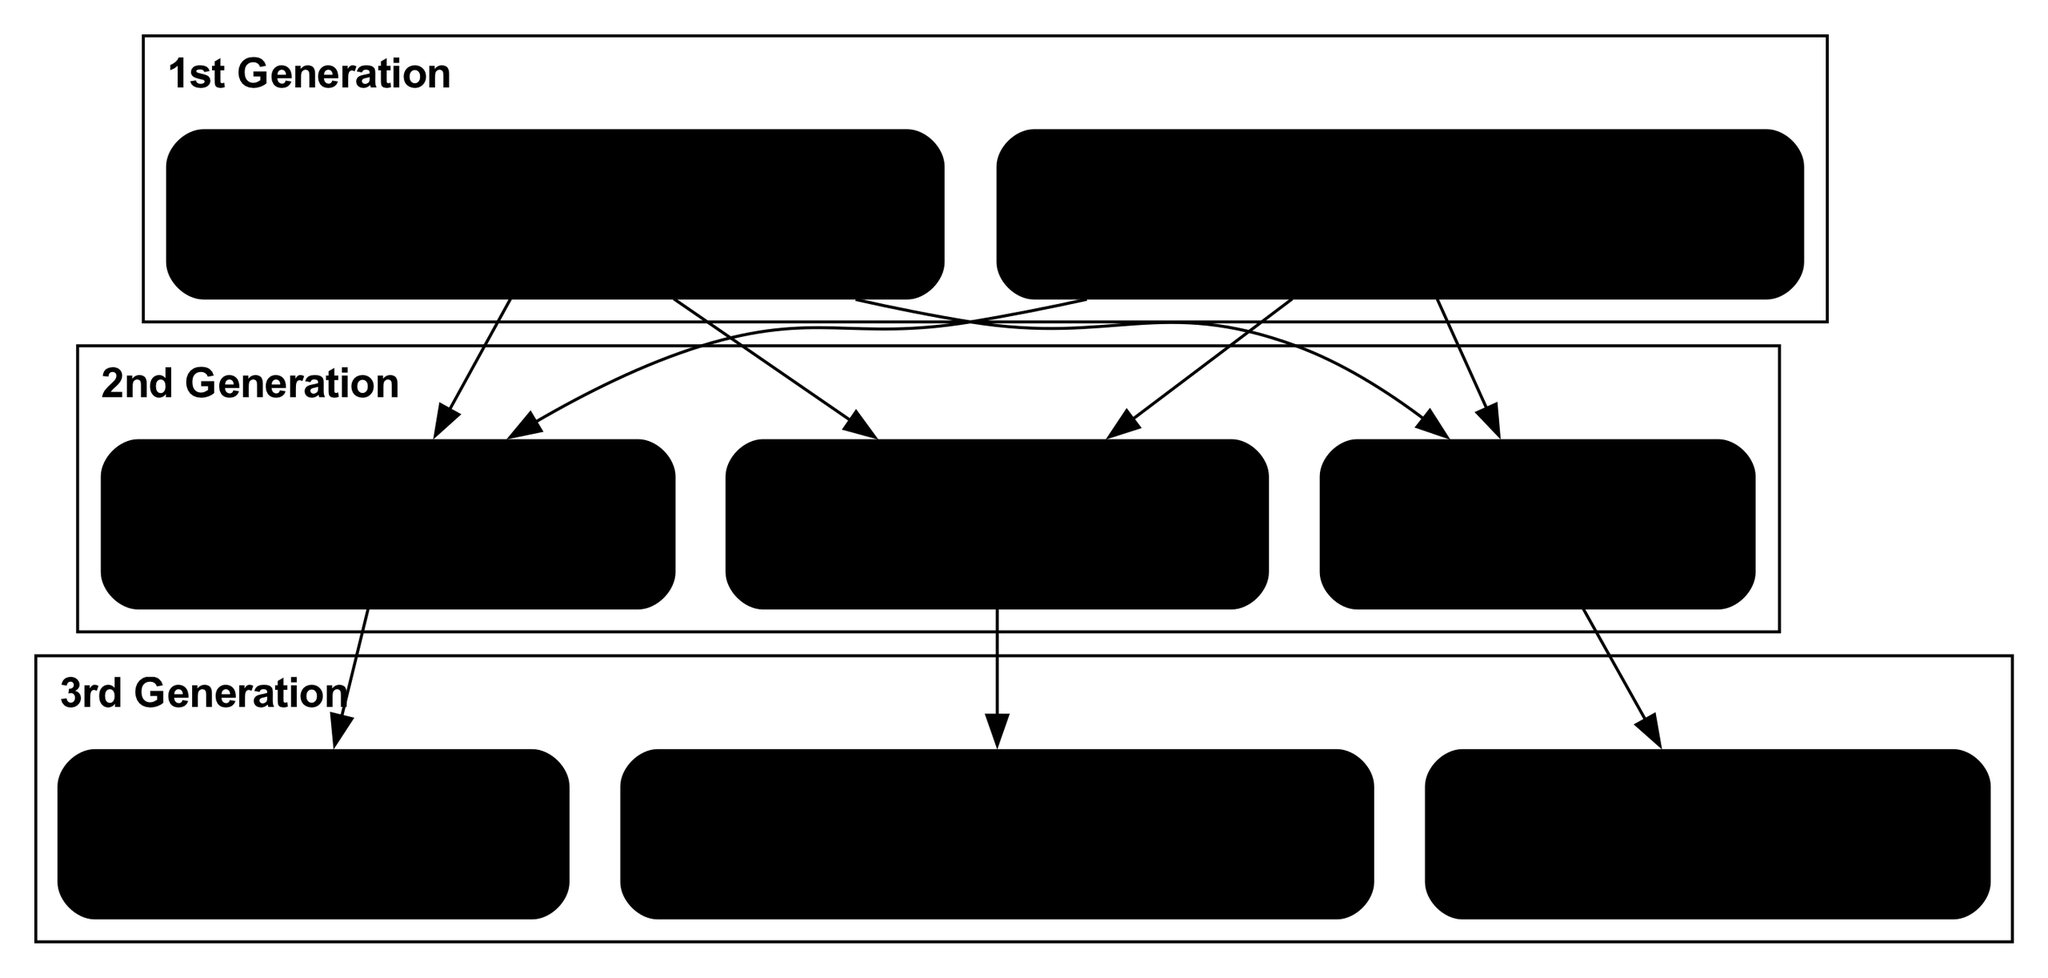What is the career of Mônica Riedel? Mônica Riedel's career is mentioned in the third generation of the family tree, where it states her profession as an Environmental Engineer.
Answer: Environmental Engineer How many members are in the 2nd generation? By counting the members listed in the second generation of the family tree, we find three individuals: Lucas Riedel, Ana Riedel, and Paulo Riedel.
Answer: 3 What notable achievement is attributed to Carla Riedel? In the first generation, Carla Riedel is noted for publishing influential research on South American politics, which is one of her significant achievements listed.
Answer: Published influential research on South American politics Who is the parent of Mônica Riedel? Tracing the family tree, Mônica Riedel is connected to her parents, Lucas Riedel and Ana Riedel. Thus, her parent is Lucas Riedel.
Answer: Lucas Riedel What career does Daniel Riedel have? In the third generation, Daniel Riedel is listed with a specific career title, which is noted as a Physician.
Answer: Physician Which member is a Professor of History? From the second generation of the family tree, Ana Riedel is identified with the career of a Professor of History.
Answer: Ana Riedel What notable achievement is Mônica Riedel recognized for? Analyzing the third generation, Mônica Riedel is recognized for pioneering sustainable energy projects, which is listed as one of her notable achievements.
Answer: Pioneered sustainable energy projects Who connects the 1st and 2nd generations? By examining the family tree, both Eduardo Riedel and Carla Riedel connect the first generation to the second generation through their children, Lucas, Ana, and Paulo.
Answer: Eduardo Riedel and Carla Riedel How is Paulo Riedel's occupation classified? In the second generation, Paulo Riedel is classified as a Business Executive, which is mentioned directly under his name.
Answer: Business Executive 